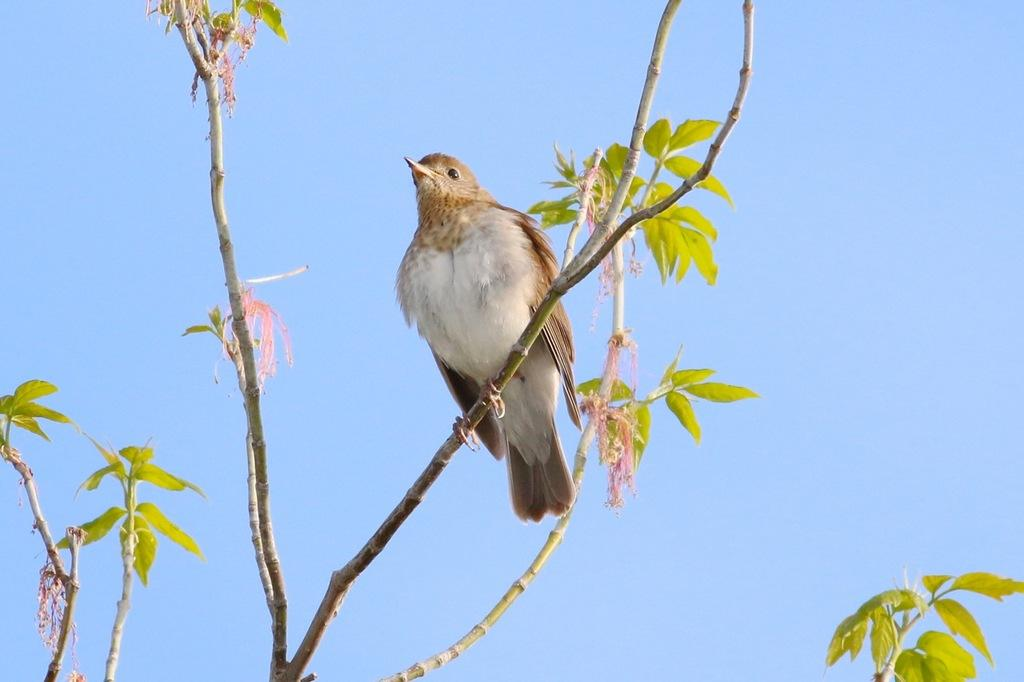What is on the branch in the image? There is a bird on a branch in the image. What type of vegetation is present in the image? Green leaves are visible in the image. What can be seen in the background of the image? The sky is visible in the background of the image. What color is the sky in the image? The sky is blue in the image. Can you hear the bird coughing in the image? There is no sound in the image, and therefore it is not possible to hear the bird coughing. 